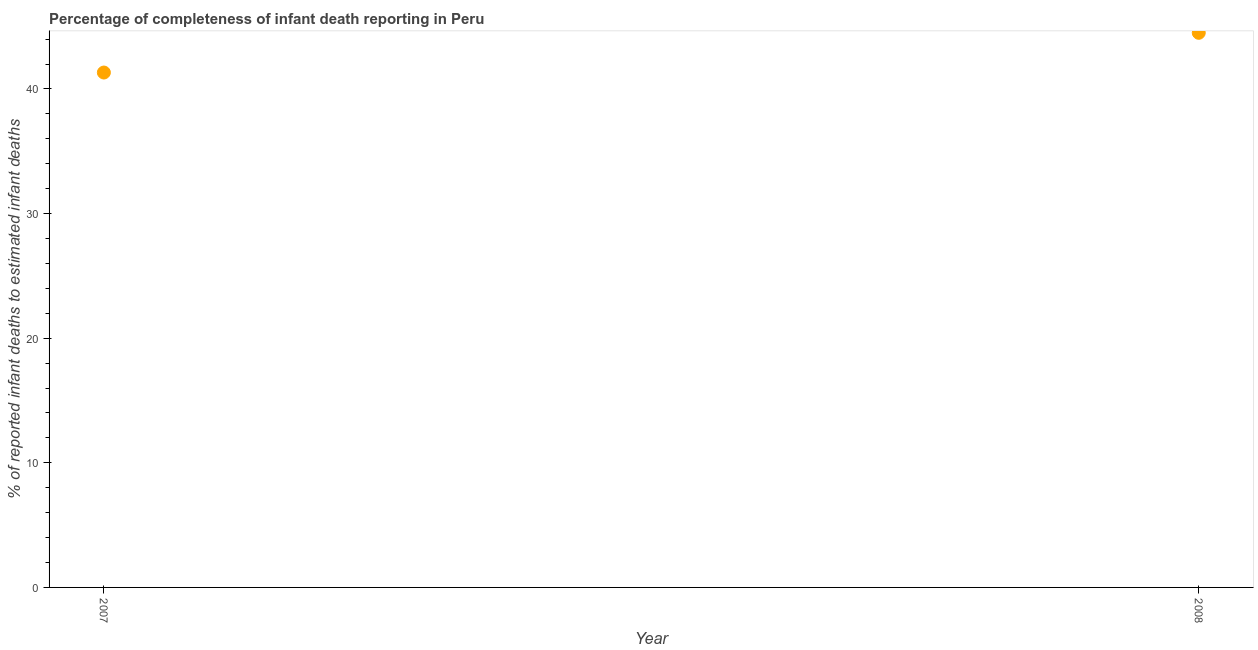What is the completeness of infant death reporting in 2007?
Offer a very short reply. 41.32. Across all years, what is the maximum completeness of infant death reporting?
Offer a very short reply. 44.51. Across all years, what is the minimum completeness of infant death reporting?
Offer a terse response. 41.32. In which year was the completeness of infant death reporting maximum?
Provide a short and direct response. 2008. In which year was the completeness of infant death reporting minimum?
Give a very brief answer. 2007. What is the sum of the completeness of infant death reporting?
Give a very brief answer. 85.83. What is the difference between the completeness of infant death reporting in 2007 and 2008?
Your answer should be very brief. -3.19. What is the average completeness of infant death reporting per year?
Offer a terse response. 42.92. What is the median completeness of infant death reporting?
Offer a terse response. 42.92. In how many years, is the completeness of infant death reporting greater than 36 %?
Ensure brevity in your answer.  2. What is the ratio of the completeness of infant death reporting in 2007 to that in 2008?
Provide a succinct answer. 0.93. Is the completeness of infant death reporting in 2007 less than that in 2008?
Offer a very short reply. Yes. In how many years, is the completeness of infant death reporting greater than the average completeness of infant death reporting taken over all years?
Offer a terse response. 1. Does the completeness of infant death reporting monotonically increase over the years?
Your answer should be very brief. Yes. How many years are there in the graph?
Your answer should be compact. 2. Are the values on the major ticks of Y-axis written in scientific E-notation?
Provide a succinct answer. No. What is the title of the graph?
Provide a short and direct response. Percentage of completeness of infant death reporting in Peru. What is the label or title of the X-axis?
Make the answer very short. Year. What is the label or title of the Y-axis?
Make the answer very short. % of reported infant deaths to estimated infant deaths. What is the % of reported infant deaths to estimated infant deaths in 2007?
Your answer should be very brief. 41.32. What is the % of reported infant deaths to estimated infant deaths in 2008?
Make the answer very short. 44.51. What is the difference between the % of reported infant deaths to estimated infant deaths in 2007 and 2008?
Keep it short and to the point. -3.19. What is the ratio of the % of reported infant deaths to estimated infant deaths in 2007 to that in 2008?
Keep it short and to the point. 0.93. 